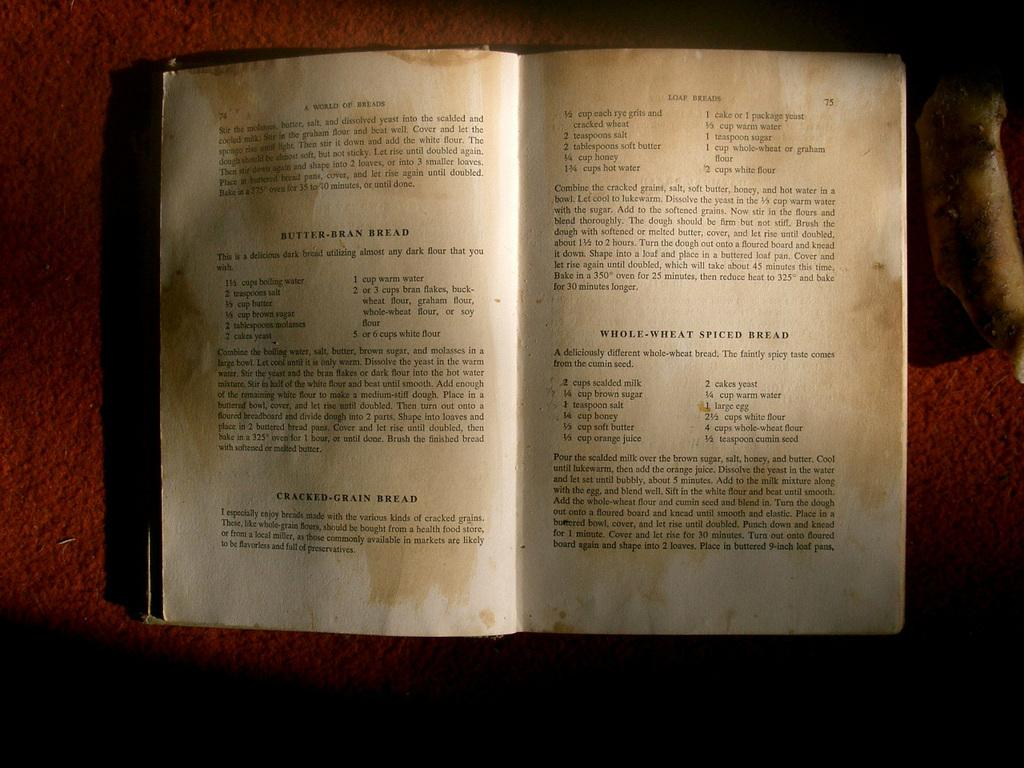<image>
Offer a succinct explanation of the picture presented. A soiled and stained cookbook gives instructions for making butter-bran bread. 